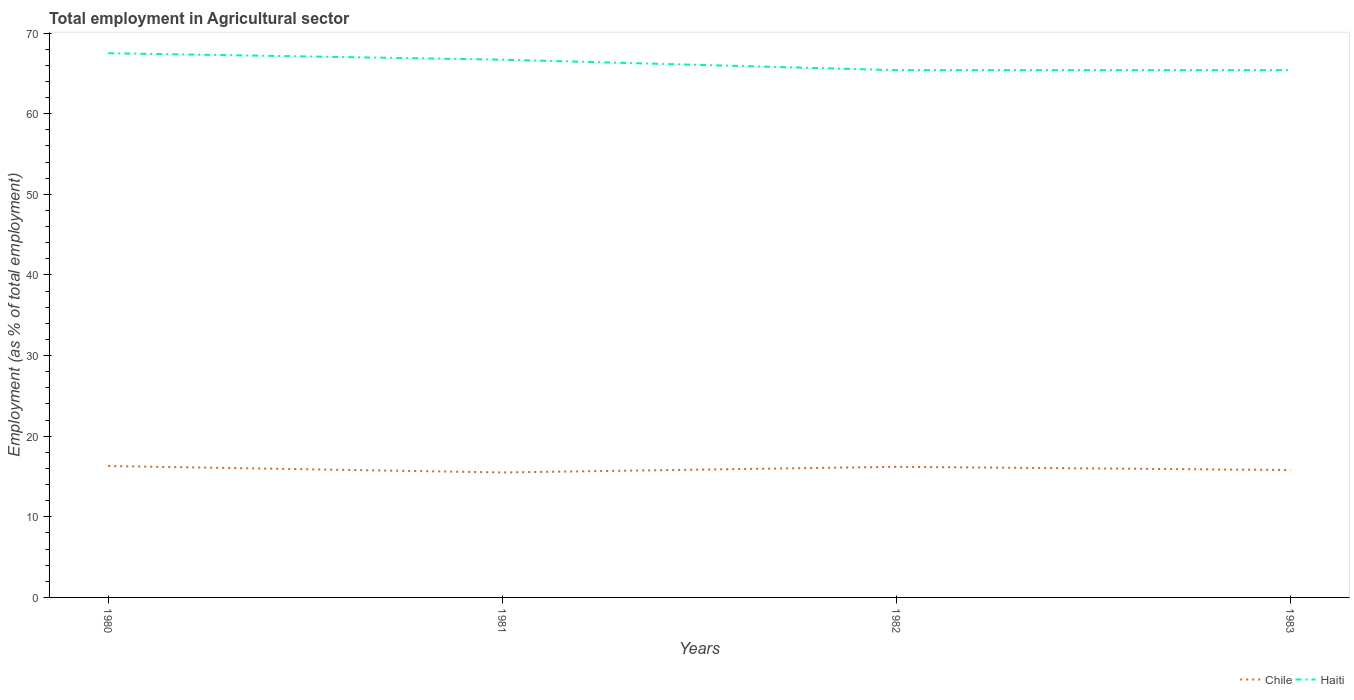Does the line corresponding to Haiti intersect with the line corresponding to Chile?
Provide a short and direct response. No. Across all years, what is the maximum employment in agricultural sector in Haiti?
Provide a short and direct response. 65.4. What is the total employment in agricultural sector in Chile in the graph?
Give a very brief answer. 0.8. What is the difference between the highest and the second highest employment in agricultural sector in Haiti?
Offer a terse response. 2.1. What is the difference between the highest and the lowest employment in agricultural sector in Haiti?
Provide a short and direct response. 2. Is the employment in agricultural sector in Haiti strictly greater than the employment in agricultural sector in Chile over the years?
Provide a short and direct response. No. How many years are there in the graph?
Make the answer very short. 4. Are the values on the major ticks of Y-axis written in scientific E-notation?
Keep it short and to the point. No. Does the graph contain any zero values?
Ensure brevity in your answer.  No. How many legend labels are there?
Give a very brief answer. 2. What is the title of the graph?
Your answer should be compact. Total employment in Agricultural sector. What is the label or title of the X-axis?
Give a very brief answer. Years. What is the label or title of the Y-axis?
Keep it short and to the point. Employment (as % of total employment). What is the Employment (as % of total employment) of Chile in 1980?
Offer a terse response. 16.3. What is the Employment (as % of total employment) of Haiti in 1980?
Offer a terse response. 67.5. What is the Employment (as % of total employment) in Chile in 1981?
Make the answer very short. 15.5. What is the Employment (as % of total employment) of Haiti in 1981?
Offer a terse response. 66.7. What is the Employment (as % of total employment) of Chile in 1982?
Your answer should be compact. 16.2. What is the Employment (as % of total employment) in Haiti in 1982?
Offer a terse response. 65.4. What is the Employment (as % of total employment) of Chile in 1983?
Your response must be concise. 15.8. What is the Employment (as % of total employment) in Haiti in 1983?
Your answer should be very brief. 65.4. Across all years, what is the maximum Employment (as % of total employment) of Chile?
Offer a very short reply. 16.3. Across all years, what is the maximum Employment (as % of total employment) in Haiti?
Your response must be concise. 67.5. Across all years, what is the minimum Employment (as % of total employment) in Haiti?
Your answer should be compact. 65.4. What is the total Employment (as % of total employment) in Chile in the graph?
Your answer should be very brief. 63.8. What is the total Employment (as % of total employment) of Haiti in the graph?
Your answer should be compact. 265. What is the difference between the Employment (as % of total employment) in Chile in 1980 and that in 1982?
Provide a short and direct response. 0.1. What is the difference between the Employment (as % of total employment) in Haiti in 1980 and that in 1982?
Your response must be concise. 2.1. What is the difference between the Employment (as % of total employment) in Chile in 1980 and that in 1983?
Your answer should be very brief. 0.5. What is the difference between the Employment (as % of total employment) in Haiti in 1980 and that in 1983?
Give a very brief answer. 2.1. What is the difference between the Employment (as % of total employment) in Chile in 1981 and that in 1982?
Your response must be concise. -0.7. What is the difference between the Employment (as % of total employment) of Haiti in 1981 and that in 1982?
Provide a short and direct response. 1.3. What is the difference between the Employment (as % of total employment) of Chile in 1982 and that in 1983?
Your answer should be compact. 0.4. What is the difference between the Employment (as % of total employment) in Chile in 1980 and the Employment (as % of total employment) in Haiti in 1981?
Give a very brief answer. -50.4. What is the difference between the Employment (as % of total employment) of Chile in 1980 and the Employment (as % of total employment) of Haiti in 1982?
Provide a short and direct response. -49.1. What is the difference between the Employment (as % of total employment) in Chile in 1980 and the Employment (as % of total employment) in Haiti in 1983?
Give a very brief answer. -49.1. What is the difference between the Employment (as % of total employment) in Chile in 1981 and the Employment (as % of total employment) in Haiti in 1982?
Your response must be concise. -49.9. What is the difference between the Employment (as % of total employment) of Chile in 1981 and the Employment (as % of total employment) of Haiti in 1983?
Ensure brevity in your answer.  -49.9. What is the difference between the Employment (as % of total employment) of Chile in 1982 and the Employment (as % of total employment) of Haiti in 1983?
Give a very brief answer. -49.2. What is the average Employment (as % of total employment) in Chile per year?
Offer a very short reply. 15.95. What is the average Employment (as % of total employment) of Haiti per year?
Make the answer very short. 66.25. In the year 1980, what is the difference between the Employment (as % of total employment) of Chile and Employment (as % of total employment) of Haiti?
Keep it short and to the point. -51.2. In the year 1981, what is the difference between the Employment (as % of total employment) of Chile and Employment (as % of total employment) of Haiti?
Provide a short and direct response. -51.2. In the year 1982, what is the difference between the Employment (as % of total employment) of Chile and Employment (as % of total employment) of Haiti?
Ensure brevity in your answer.  -49.2. In the year 1983, what is the difference between the Employment (as % of total employment) of Chile and Employment (as % of total employment) of Haiti?
Your answer should be compact. -49.6. What is the ratio of the Employment (as % of total employment) in Chile in 1980 to that in 1981?
Offer a very short reply. 1.05. What is the ratio of the Employment (as % of total employment) of Haiti in 1980 to that in 1982?
Your answer should be very brief. 1.03. What is the ratio of the Employment (as % of total employment) in Chile in 1980 to that in 1983?
Your answer should be very brief. 1.03. What is the ratio of the Employment (as % of total employment) of Haiti in 1980 to that in 1983?
Provide a succinct answer. 1.03. What is the ratio of the Employment (as % of total employment) of Chile in 1981 to that in 1982?
Make the answer very short. 0.96. What is the ratio of the Employment (as % of total employment) in Haiti in 1981 to that in 1982?
Your response must be concise. 1.02. What is the ratio of the Employment (as % of total employment) of Haiti in 1981 to that in 1983?
Your answer should be compact. 1.02. What is the ratio of the Employment (as % of total employment) in Chile in 1982 to that in 1983?
Your answer should be very brief. 1.03. What is the ratio of the Employment (as % of total employment) of Haiti in 1982 to that in 1983?
Offer a terse response. 1. What is the difference between the highest and the lowest Employment (as % of total employment) in Chile?
Provide a succinct answer. 0.8. 